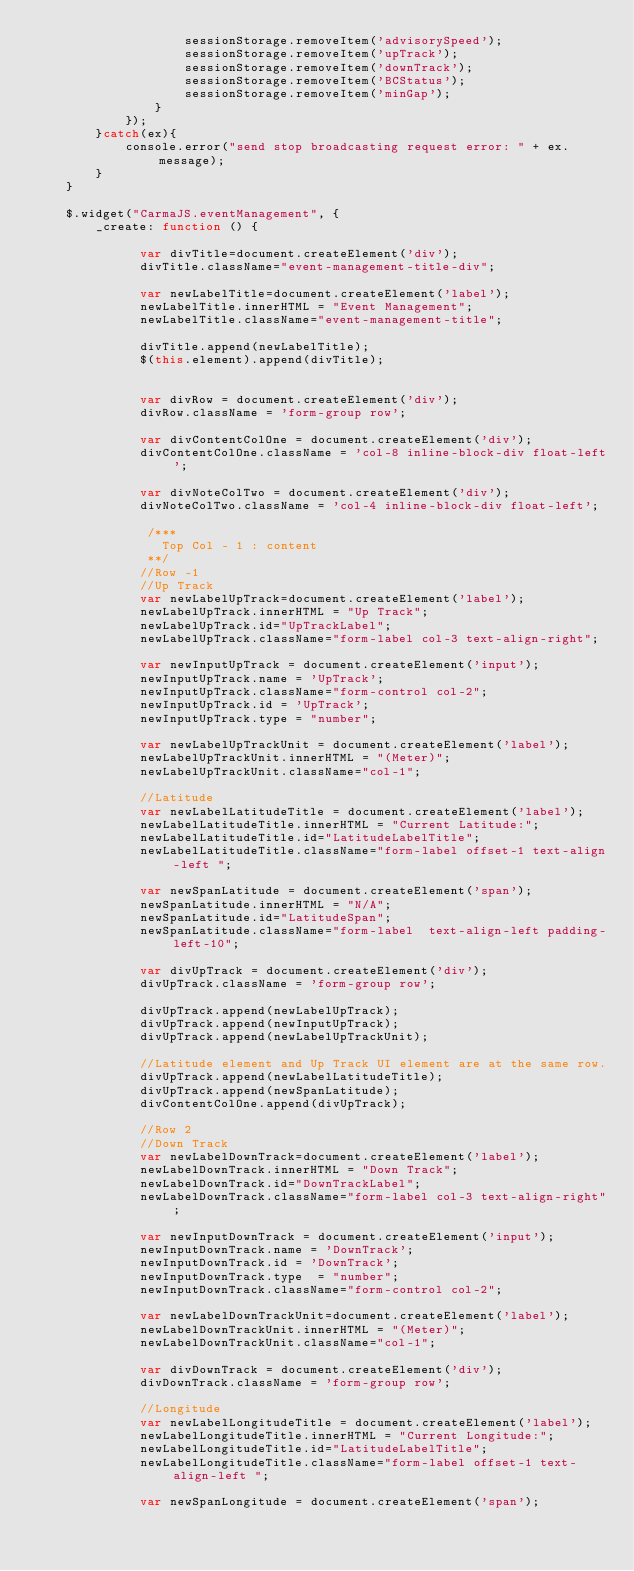<code> <loc_0><loc_0><loc_500><loc_500><_JavaScript_>                    sessionStorage.removeItem('advisorySpeed');
                    sessionStorage.removeItem('upTrack');
                    sessionStorage.removeItem('downTrack');
                    sessionStorage.removeItem('BCStatus');
                    sessionStorage.removeItem('minGap');
                }
            });
        }catch(ex){
            console.error("send stop broadcasting request error: " + ex.message);
        }
    }

    $.widget("CarmaJS.eventManagement", {
        _create: function () {

              var divTitle=document.createElement('div');
              divTitle.className="event-management-title-div";

              var newLabelTitle=document.createElement('label');
              newLabelTitle.innerHTML = "Event Management";
              newLabelTitle.className="event-management-title";

              divTitle.append(newLabelTitle);
              $(this.element).append(divTitle);


              var divRow = document.createElement('div');
              divRow.className = 'form-group row';

              var divContentColOne = document.createElement('div');
              divContentColOne.className = 'col-8 inline-block-div float-left';

              var divNoteColTwo = document.createElement('div');
              divNoteColTwo.className = 'col-4 inline-block-div float-left';

               /***
                 Top Col - 1 : content
               **/
              //Row -1
              //Up Track
              var newLabelUpTrack=document.createElement('label');
              newLabelUpTrack.innerHTML = "Up Track";
              newLabelUpTrack.id="UpTrackLabel";
              newLabelUpTrack.className="form-label col-3 text-align-right";

              var newInputUpTrack = document.createElement('input');
              newInputUpTrack.name = 'UpTrack';
              newInputUpTrack.className="form-control col-2";
              newInputUpTrack.id = 'UpTrack';
              newInputUpTrack.type = "number";

              var newLabelUpTrackUnit = document.createElement('label');
              newLabelUpTrackUnit.innerHTML = "(Meter)";
              newLabelUpTrackUnit.className="col-1";

              //Latitude
              var newLabelLatitudeTitle = document.createElement('label');
              newLabelLatitudeTitle.innerHTML = "Current Latitude:";
              newLabelLatitudeTitle.id="LatitudeLabelTitle";
              newLabelLatitudeTitle.className="form-label offset-1 text-align-left ";

              var newSpanLatitude = document.createElement('span');
              newSpanLatitude.innerHTML = "N/A";
              newSpanLatitude.id="LatitudeSpan";
              newSpanLatitude.className="form-label  text-align-left padding-left-10";

              var divUpTrack = document.createElement('div');
              divUpTrack.className = 'form-group row';

              divUpTrack.append(newLabelUpTrack);
              divUpTrack.append(newInputUpTrack);
              divUpTrack.append(newLabelUpTrackUnit);

              //Latitude element and Up Track UI element are at the same row.
              divUpTrack.append(newLabelLatitudeTitle);
              divUpTrack.append(newSpanLatitude);
              divContentColOne.append(divUpTrack);

              //Row 2
              //Down Track
              var newLabelDownTrack=document.createElement('label');
              newLabelDownTrack.innerHTML = "Down Track";
              newLabelDownTrack.id="DownTrackLabel";
              newLabelDownTrack.className="form-label col-3 text-align-right";

              var newInputDownTrack = document.createElement('input');
              newInputDownTrack.name = 'DownTrack';
              newInputDownTrack.id = 'DownTrack';
              newInputDownTrack.type  = "number";
              newInputDownTrack.className="form-control col-2";

              var newLabelDownTrackUnit=document.createElement('label');
              newLabelDownTrackUnit.innerHTML = "(Meter)";
              newLabelDownTrackUnit.className="col-1";

              var divDownTrack = document.createElement('div');
              divDownTrack.className = 'form-group row';

              //Longitude
              var newLabelLongitudeTitle = document.createElement('label');
              newLabelLongitudeTitle.innerHTML = "Current Longitude:";
              newLabelLongitudeTitle.id="LatitudeLabelTitle";
              newLabelLongitudeTitle.className="form-label offset-1 text-align-left ";

              var newSpanLongitude = document.createElement('span');</code> 